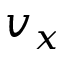Convert formula to latex. <formula><loc_0><loc_0><loc_500><loc_500>v _ { x }</formula> 